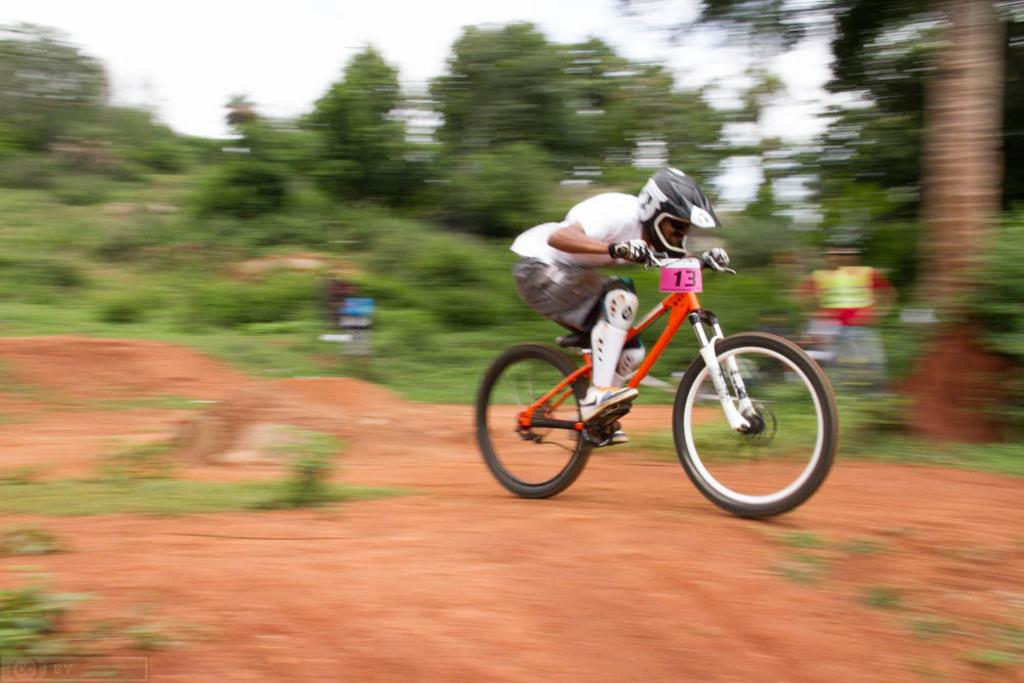What is the man in the image doing? The man is cycling in the image. What is the man wearing while cycling? The man is wearing a white t-shirt and a helmet. What can be seen in the background of the image? There are trees in the background of the image. Are there any other people present in the image? Yes, there is at least one other person in the image. What type of toy is the man learning to use in the image? There is no toy or learning activity depicted in the image; the man is simply cycling. Can you see any seeds being planted in the image? There is no indication of any seeds or planting activity in the image; it features a man cycling with trees in the background. 